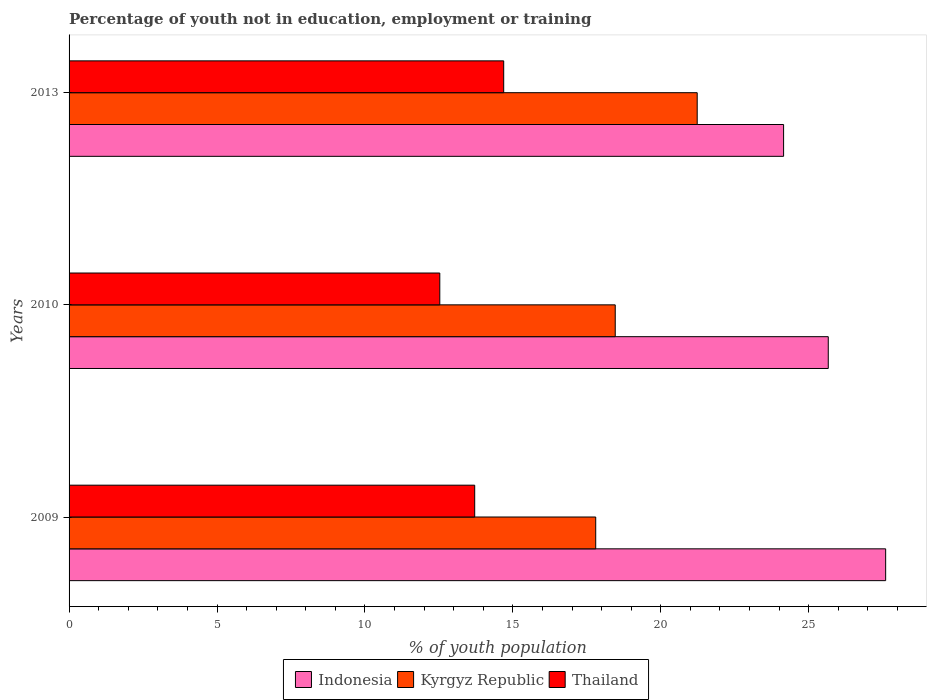How many different coloured bars are there?
Give a very brief answer. 3. Are the number of bars per tick equal to the number of legend labels?
Your response must be concise. Yes. In how many cases, is the number of bars for a given year not equal to the number of legend labels?
Your response must be concise. 0. What is the percentage of unemployed youth population in in Thailand in 2009?
Ensure brevity in your answer.  13.71. Across all years, what is the maximum percentage of unemployed youth population in in Kyrgyz Republic?
Your answer should be very brief. 21.23. Across all years, what is the minimum percentage of unemployed youth population in in Thailand?
Give a very brief answer. 12.53. In which year was the percentage of unemployed youth population in in Kyrgyz Republic maximum?
Ensure brevity in your answer.  2013. What is the total percentage of unemployed youth population in in Indonesia in the graph?
Give a very brief answer. 77.41. What is the difference between the percentage of unemployed youth population in in Thailand in 2009 and that in 2013?
Your answer should be very brief. -0.98. What is the difference between the percentage of unemployed youth population in in Indonesia in 2009 and the percentage of unemployed youth population in in Kyrgyz Republic in 2013?
Make the answer very short. 6.37. What is the average percentage of unemployed youth population in in Indonesia per year?
Offer a terse response. 25.8. In the year 2009, what is the difference between the percentage of unemployed youth population in in Thailand and percentage of unemployed youth population in in Kyrgyz Republic?
Your answer should be very brief. -4.09. In how many years, is the percentage of unemployed youth population in in Kyrgyz Republic greater than 9 %?
Provide a succinct answer. 3. What is the ratio of the percentage of unemployed youth population in in Kyrgyz Republic in 2010 to that in 2013?
Your answer should be very brief. 0.87. Is the difference between the percentage of unemployed youth population in in Thailand in 2010 and 2013 greater than the difference between the percentage of unemployed youth population in in Kyrgyz Republic in 2010 and 2013?
Ensure brevity in your answer.  Yes. What is the difference between the highest and the second highest percentage of unemployed youth population in in Kyrgyz Republic?
Your answer should be compact. 2.77. What is the difference between the highest and the lowest percentage of unemployed youth population in in Indonesia?
Your answer should be compact. 3.45. In how many years, is the percentage of unemployed youth population in in Indonesia greater than the average percentage of unemployed youth population in in Indonesia taken over all years?
Offer a very short reply. 1. What does the 2nd bar from the top in 2009 represents?
Offer a very short reply. Kyrgyz Republic. What does the 3rd bar from the bottom in 2009 represents?
Give a very brief answer. Thailand. Is it the case that in every year, the sum of the percentage of unemployed youth population in in Kyrgyz Republic and percentage of unemployed youth population in in Indonesia is greater than the percentage of unemployed youth population in in Thailand?
Offer a terse response. Yes. How many bars are there?
Offer a very short reply. 9. Are all the bars in the graph horizontal?
Keep it short and to the point. Yes. How many years are there in the graph?
Make the answer very short. 3. What is the difference between two consecutive major ticks on the X-axis?
Your answer should be compact. 5. Does the graph contain grids?
Your answer should be compact. No. How are the legend labels stacked?
Your answer should be very brief. Horizontal. What is the title of the graph?
Give a very brief answer. Percentage of youth not in education, employment or training. What is the label or title of the X-axis?
Provide a succinct answer. % of youth population. What is the label or title of the Y-axis?
Give a very brief answer. Years. What is the % of youth population of Indonesia in 2009?
Offer a very short reply. 27.6. What is the % of youth population of Kyrgyz Republic in 2009?
Your response must be concise. 17.8. What is the % of youth population of Thailand in 2009?
Provide a succinct answer. 13.71. What is the % of youth population in Indonesia in 2010?
Offer a terse response. 25.66. What is the % of youth population in Kyrgyz Republic in 2010?
Make the answer very short. 18.46. What is the % of youth population in Thailand in 2010?
Offer a very short reply. 12.53. What is the % of youth population in Indonesia in 2013?
Keep it short and to the point. 24.15. What is the % of youth population of Kyrgyz Republic in 2013?
Provide a succinct answer. 21.23. What is the % of youth population in Thailand in 2013?
Ensure brevity in your answer.  14.69. Across all years, what is the maximum % of youth population in Indonesia?
Your answer should be compact. 27.6. Across all years, what is the maximum % of youth population of Kyrgyz Republic?
Give a very brief answer. 21.23. Across all years, what is the maximum % of youth population of Thailand?
Your answer should be compact. 14.69. Across all years, what is the minimum % of youth population of Indonesia?
Ensure brevity in your answer.  24.15. Across all years, what is the minimum % of youth population of Kyrgyz Republic?
Give a very brief answer. 17.8. Across all years, what is the minimum % of youth population of Thailand?
Provide a short and direct response. 12.53. What is the total % of youth population in Indonesia in the graph?
Your answer should be compact. 77.41. What is the total % of youth population in Kyrgyz Republic in the graph?
Provide a succinct answer. 57.49. What is the total % of youth population of Thailand in the graph?
Offer a very short reply. 40.93. What is the difference between the % of youth population of Indonesia in 2009 and that in 2010?
Offer a terse response. 1.94. What is the difference between the % of youth population in Kyrgyz Republic in 2009 and that in 2010?
Provide a short and direct response. -0.66. What is the difference between the % of youth population in Thailand in 2009 and that in 2010?
Provide a short and direct response. 1.18. What is the difference between the % of youth population of Indonesia in 2009 and that in 2013?
Your answer should be compact. 3.45. What is the difference between the % of youth population of Kyrgyz Republic in 2009 and that in 2013?
Make the answer very short. -3.43. What is the difference between the % of youth population in Thailand in 2009 and that in 2013?
Your answer should be compact. -0.98. What is the difference between the % of youth population in Indonesia in 2010 and that in 2013?
Ensure brevity in your answer.  1.51. What is the difference between the % of youth population of Kyrgyz Republic in 2010 and that in 2013?
Your answer should be very brief. -2.77. What is the difference between the % of youth population of Thailand in 2010 and that in 2013?
Provide a short and direct response. -2.16. What is the difference between the % of youth population of Indonesia in 2009 and the % of youth population of Kyrgyz Republic in 2010?
Your answer should be very brief. 9.14. What is the difference between the % of youth population of Indonesia in 2009 and the % of youth population of Thailand in 2010?
Offer a very short reply. 15.07. What is the difference between the % of youth population in Kyrgyz Republic in 2009 and the % of youth population in Thailand in 2010?
Your answer should be compact. 5.27. What is the difference between the % of youth population in Indonesia in 2009 and the % of youth population in Kyrgyz Republic in 2013?
Give a very brief answer. 6.37. What is the difference between the % of youth population in Indonesia in 2009 and the % of youth population in Thailand in 2013?
Provide a short and direct response. 12.91. What is the difference between the % of youth population in Kyrgyz Republic in 2009 and the % of youth population in Thailand in 2013?
Your answer should be compact. 3.11. What is the difference between the % of youth population of Indonesia in 2010 and the % of youth population of Kyrgyz Republic in 2013?
Your answer should be very brief. 4.43. What is the difference between the % of youth population of Indonesia in 2010 and the % of youth population of Thailand in 2013?
Provide a succinct answer. 10.97. What is the difference between the % of youth population of Kyrgyz Republic in 2010 and the % of youth population of Thailand in 2013?
Your response must be concise. 3.77. What is the average % of youth population of Indonesia per year?
Provide a succinct answer. 25.8. What is the average % of youth population of Kyrgyz Republic per year?
Give a very brief answer. 19.16. What is the average % of youth population in Thailand per year?
Give a very brief answer. 13.64. In the year 2009, what is the difference between the % of youth population of Indonesia and % of youth population of Thailand?
Provide a short and direct response. 13.89. In the year 2009, what is the difference between the % of youth population of Kyrgyz Republic and % of youth population of Thailand?
Your response must be concise. 4.09. In the year 2010, what is the difference between the % of youth population of Indonesia and % of youth population of Kyrgyz Republic?
Your answer should be compact. 7.2. In the year 2010, what is the difference between the % of youth population of Indonesia and % of youth population of Thailand?
Your answer should be compact. 13.13. In the year 2010, what is the difference between the % of youth population in Kyrgyz Republic and % of youth population in Thailand?
Your answer should be very brief. 5.93. In the year 2013, what is the difference between the % of youth population in Indonesia and % of youth population in Kyrgyz Republic?
Give a very brief answer. 2.92. In the year 2013, what is the difference between the % of youth population in Indonesia and % of youth population in Thailand?
Ensure brevity in your answer.  9.46. In the year 2013, what is the difference between the % of youth population of Kyrgyz Republic and % of youth population of Thailand?
Your response must be concise. 6.54. What is the ratio of the % of youth population in Indonesia in 2009 to that in 2010?
Make the answer very short. 1.08. What is the ratio of the % of youth population in Kyrgyz Republic in 2009 to that in 2010?
Offer a very short reply. 0.96. What is the ratio of the % of youth population in Thailand in 2009 to that in 2010?
Ensure brevity in your answer.  1.09. What is the ratio of the % of youth population in Kyrgyz Republic in 2009 to that in 2013?
Give a very brief answer. 0.84. What is the ratio of the % of youth population of Thailand in 2009 to that in 2013?
Your answer should be compact. 0.93. What is the ratio of the % of youth population in Kyrgyz Republic in 2010 to that in 2013?
Make the answer very short. 0.87. What is the ratio of the % of youth population in Thailand in 2010 to that in 2013?
Your answer should be very brief. 0.85. What is the difference between the highest and the second highest % of youth population in Indonesia?
Offer a terse response. 1.94. What is the difference between the highest and the second highest % of youth population of Kyrgyz Republic?
Give a very brief answer. 2.77. What is the difference between the highest and the lowest % of youth population in Indonesia?
Make the answer very short. 3.45. What is the difference between the highest and the lowest % of youth population of Kyrgyz Republic?
Offer a terse response. 3.43. What is the difference between the highest and the lowest % of youth population of Thailand?
Keep it short and to the point. 2.16. 